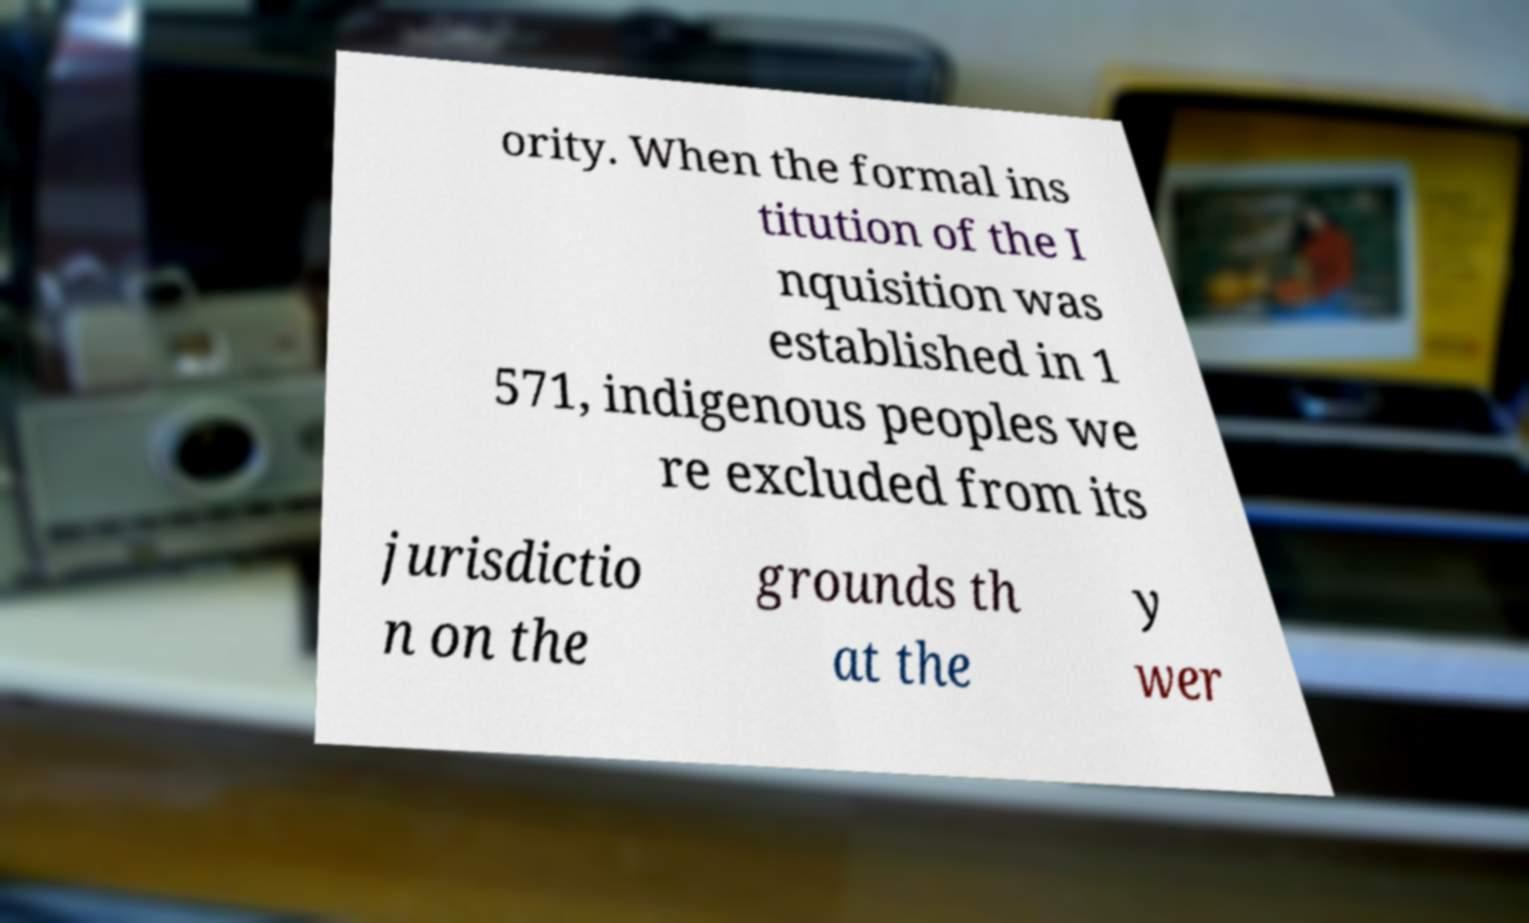There's text embedded in this image that I need extracted. Can you transcribe it verbatim? ority. When the formal ins titution of the I nquisition was established in 1 571, indigenous peoples we re excluded from its jurisdictio n on the grounds th at the y wer 